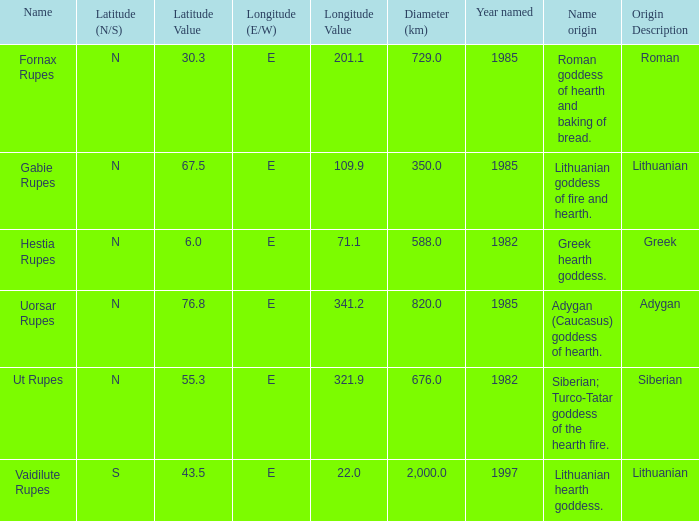What was the width of the characteristic discovered in 1997? 2000.0. 